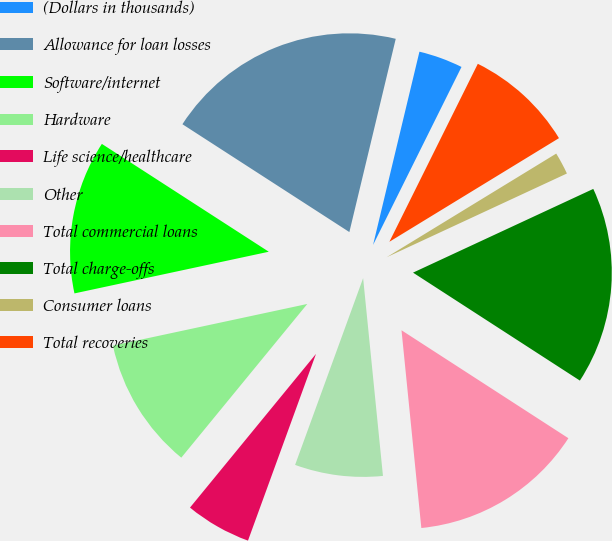Convert chart. <chart><loc_0><loc_0><loc_500><loc_500><pie_chart><fcel>(Dollars in thousands)<fcel>Allowance for loan losses<fcel>Software/internet<fcel>Hardware<fcel>Life science/healthcare<fcel>Other<fcel>Total commercial loans<fcel>Total charge-offs<fcel>Consumer loans<fcel>Total recoveries<nl><fcel>3.59%<fcel>19.62%<fcel>12.49%<fcel>10.71%<fcel>5.37%<fcel>7.15%<fcel>14.27%<fcel>16.06%<fcel>1.81%<fcel>8.93%<nl></chart> 